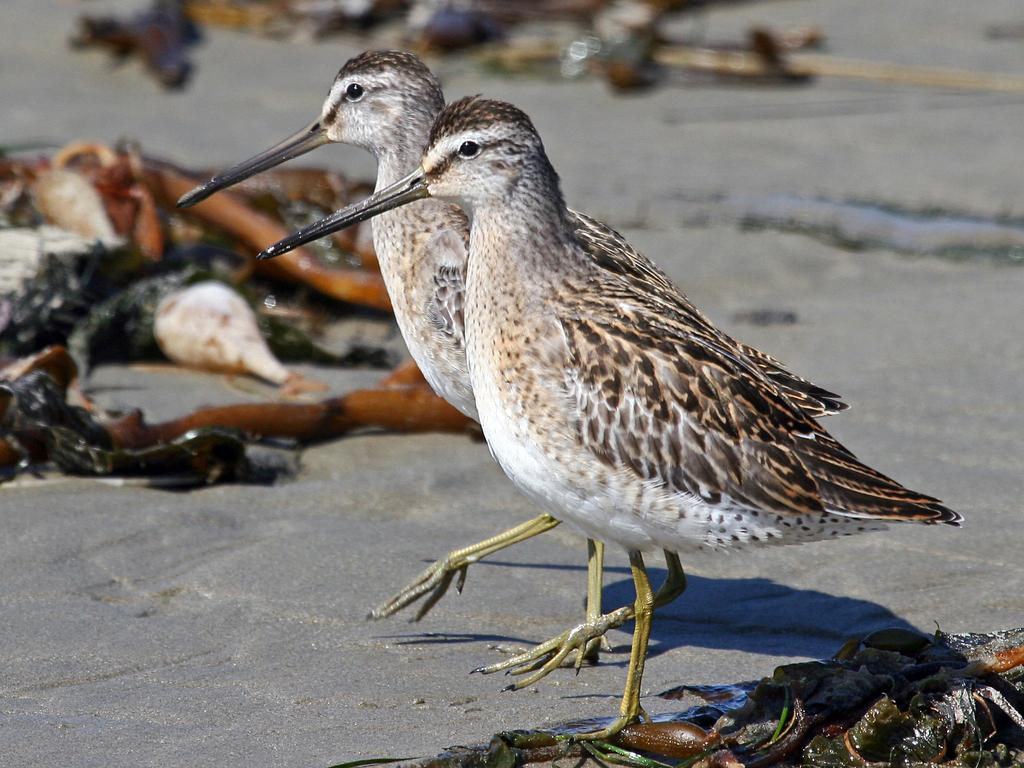What type of animals are on the ground in the image? There are birds on the ground in the image. What color are the birds? The birds are brown in color. What features do the birds have? The birds have eyes, beaks, and legs. What type of ink can be seen on the birds in the image? There is no ink present on the birds in the image; they are simply brown in color. 